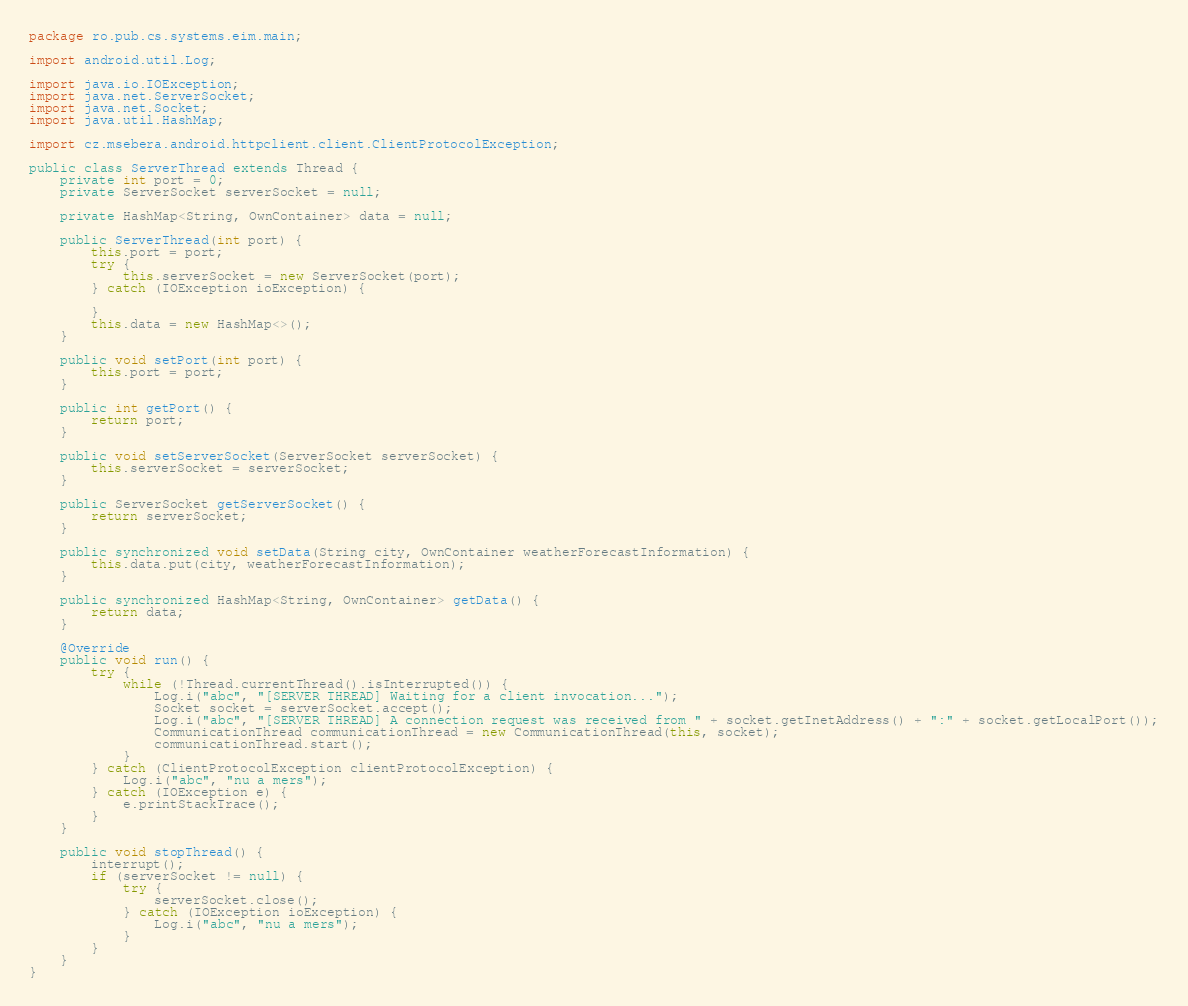Convert code to text. <code><loc_0><loc_0><loc_500><loc_500><_Java_>package ro.pub.cs.systems.eim.main;

import android.util.Log;

import java.io.IOException;
import java.net.ServerSocket;
import java.net.Socket;
import java.util.HashMap;

import cz.msebera.android.httpclient.client.ClientProtocolException;

public class ServerThread extends Thread {
    private int port = 0;
    private ServerSocket serverSocket = null;

    private HashMap<String, OwnContainer> data = null;

    public ServerThread(int port) {
        this.port = port;
        try {
            this.serverSocket = new ServerSocket(port);
        } catch (IOException ioException) {

        }
        this.data = new HashMap<>();
    }

    public void setPort(int port) {
        this.port = port;
    }

    public int getPort() {
        return port;
    }

    public void setServerSocket(ServerSocket serverSocket) {
        this.serverSocket = serverSocket;
    }

    public ServerSocket getServerSocket() {
        return serverSocket;
    }

    public synchronized void setData(String city, OwnContainer weatherForecastInformation) {
        this.data.put(city, weatherForecastInformation);
    }

    public synchronized HashMap<String, OwnContainer> getData() {
        return data;
    }

    @Override
    public void run() {
        try {
            while (!Thread.currentThread().isInterrupted()) {
                Log.i("abc", "[SERVER THREAD] Waiting for a client invocation...");
                Socket socket = serverSocket.accept();
                Log.i("abc", "[SERVER THREAD] A connection request was received from " + socket.getInetAddress() + ":" + socket.getLocalPort());
                CommunicationThread communicationThread = new CommunicationThread(this, socket);
                communicationThread.start();
            }
        } catch (ClientProtocolException clientProtocolException) {
            Log.i("abc", "nu a mers");
        } catch (IOException e) {
            e.printStackTrace();
        }
    }

    public void stopThread() {
        interrupt();
        if (serverSocket != null) {
            try {
                serverSocket.close();
            } catch (IOException ioException) {
                Log.i("abc", "nu a mers");
            }
        }
    }
}</code> 